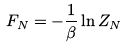<formula> <loc_0><loc_0><loc_500><loc_500>F _ { N } = - \frac { 1 } { \beta } \ln Z _ { N }</formula> 